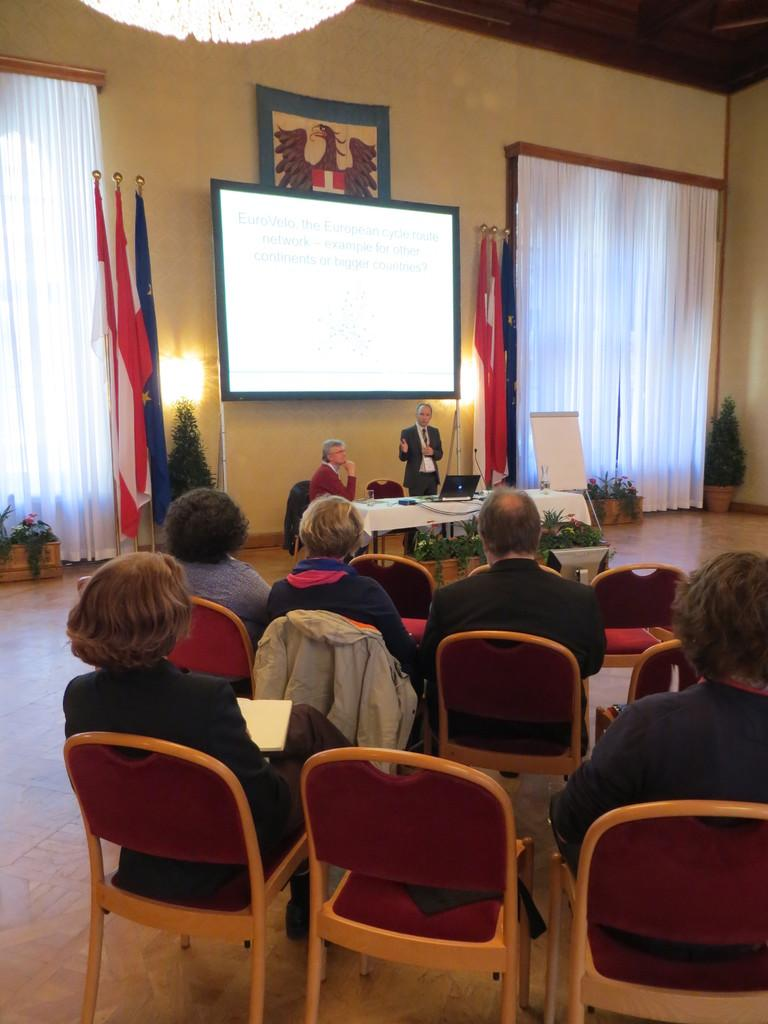What type of setting is shown in the image? The image depicts a meeting room. What are the people in the room doing? There are people seated in the room, and a man is standing and speaking with a microphone. What device is present in the room for displaying visuals? There is a projector in the room. What decorative elements are present in the room? There are flags on the side of the room. What type of shop can be seen in the background of the image? There is no shop present in the image; it depicts a meeting room. How does the man roll the microphone across the room? The man is not rolling the microphone across the room; he is standing and speaking with it. 